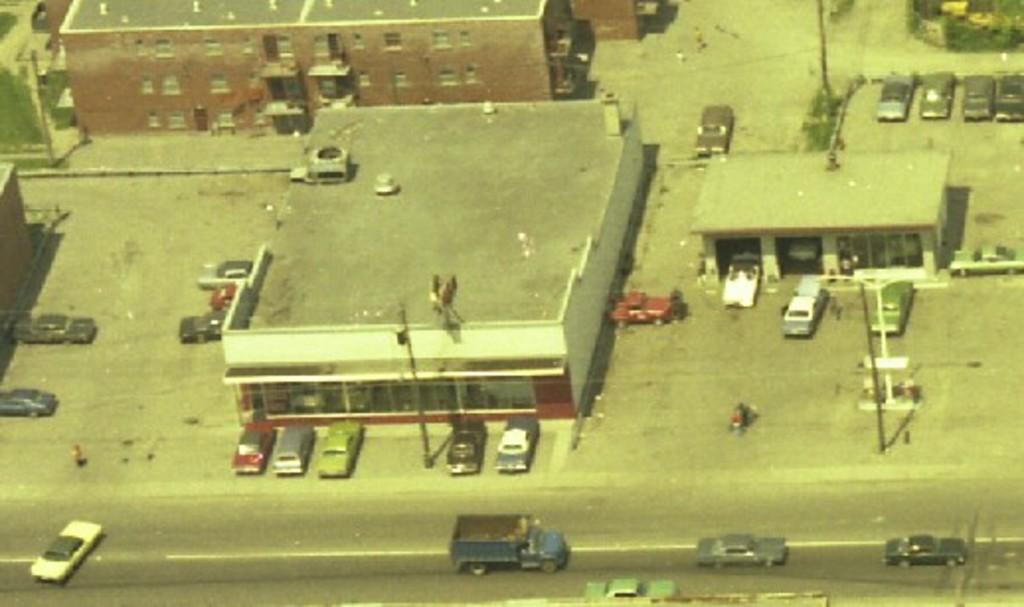What type of view is shown in the image? The image is an aerial view of a town. What can be seen around the buildings in the image? There are many cars visible in the image, and they are around the buildings. Are the cars in the image stationary or moving? Some cars are moving on the roads in the image. Can you see a volleyball game happening in the image? There is no volleyball game present in the image. What type of ray is visible in the image? There is no ray visible in the image. 